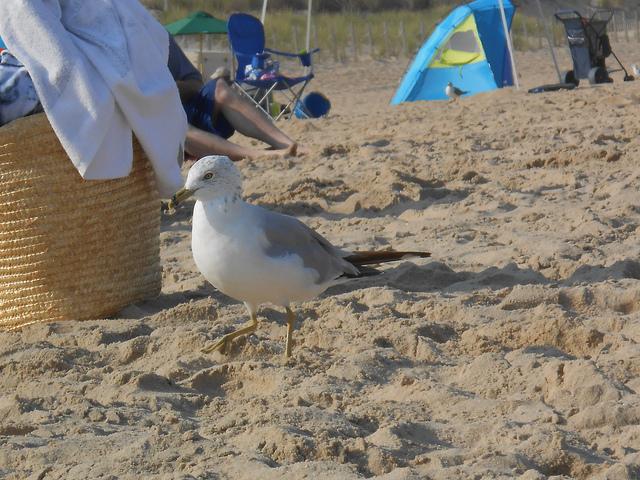What is the seagull standing by?
Write a very short answer. Basket. Is this likely a farm animal?
Answer briefly. No. How many birds are there?
Write a very short answer. 1. What type of bird is this?
Quick response, please. Seagull. What kind of bird is this?
Quick response, please. Seagull. Is the bird near water?
Concise answer only. Yes. Is the ground soft?
Keep it brief. Yes. What color is the fauna?
Concise answer only. White. How many bears are pictured?
Be succinct. 0. 